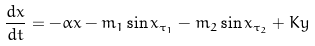Convert formula to latex. <formula><loc_0><loc_0><loc_500><loc_500>\frac { d x } { d t } = - \alpha x - m _ { 1 } \sin x _ { \tau _ { 1 } } - m _ { 2 } \sin x _ { \tau _ { 2 } } + K y</formula> 